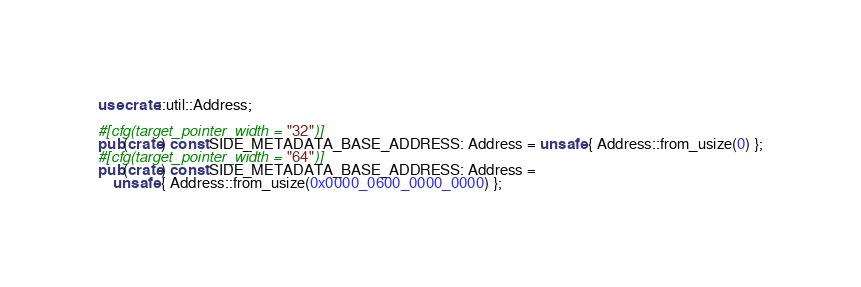Convert code to text. <code><loc_0><loc_0><loc_500><loc_500><_Rust_>use crate::util::Address;

#[cfg(target_pointer_width = "32")]
pub(crate) const SIDE_METADATA_BASE_ADDRESS: Address = unsafe { Address::from_usize(0) };
#[cfg(target_pointer_width = "64")]
pub(crate) const SIDE_METADATA_BASE_ADDRESS: Address =
    unsafe { Address::from_usize(0x0000_0600_0000_0000) };
</code> 